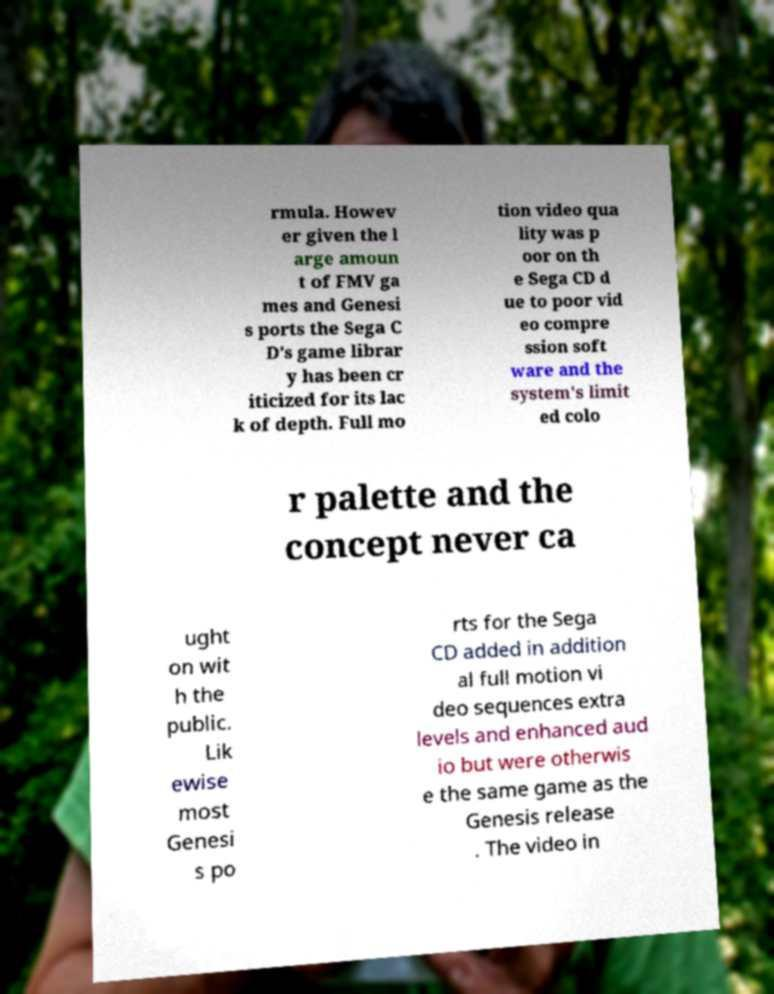What messages or text are displayed in this image? I need them in a readable, typed format. rmula. Howev er given the l arge amoun t of FMV ga mes and Genesi s ports the Sega C D's game librar y has been cr iticized for its lac k of depth. Full mo tion video qua lity was p oor on th e Sega CD d ue to poor vid eo compre ssion soft ware and the system's limit ed colo r palette and the concept never ca ught on wit h the public. Lik ewise most Genesi s po rts for the Sega CD added in addition al full motion vi deo sequences extra levels and enhanced aud io but were otherwis e the same game as the Genesis release . The video in 